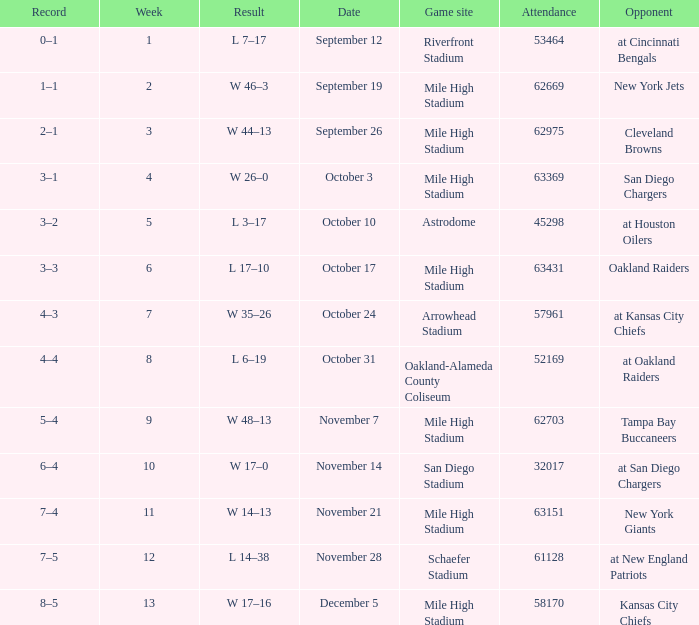What was the week number when the opponent was the New York Jets? 2.0. 